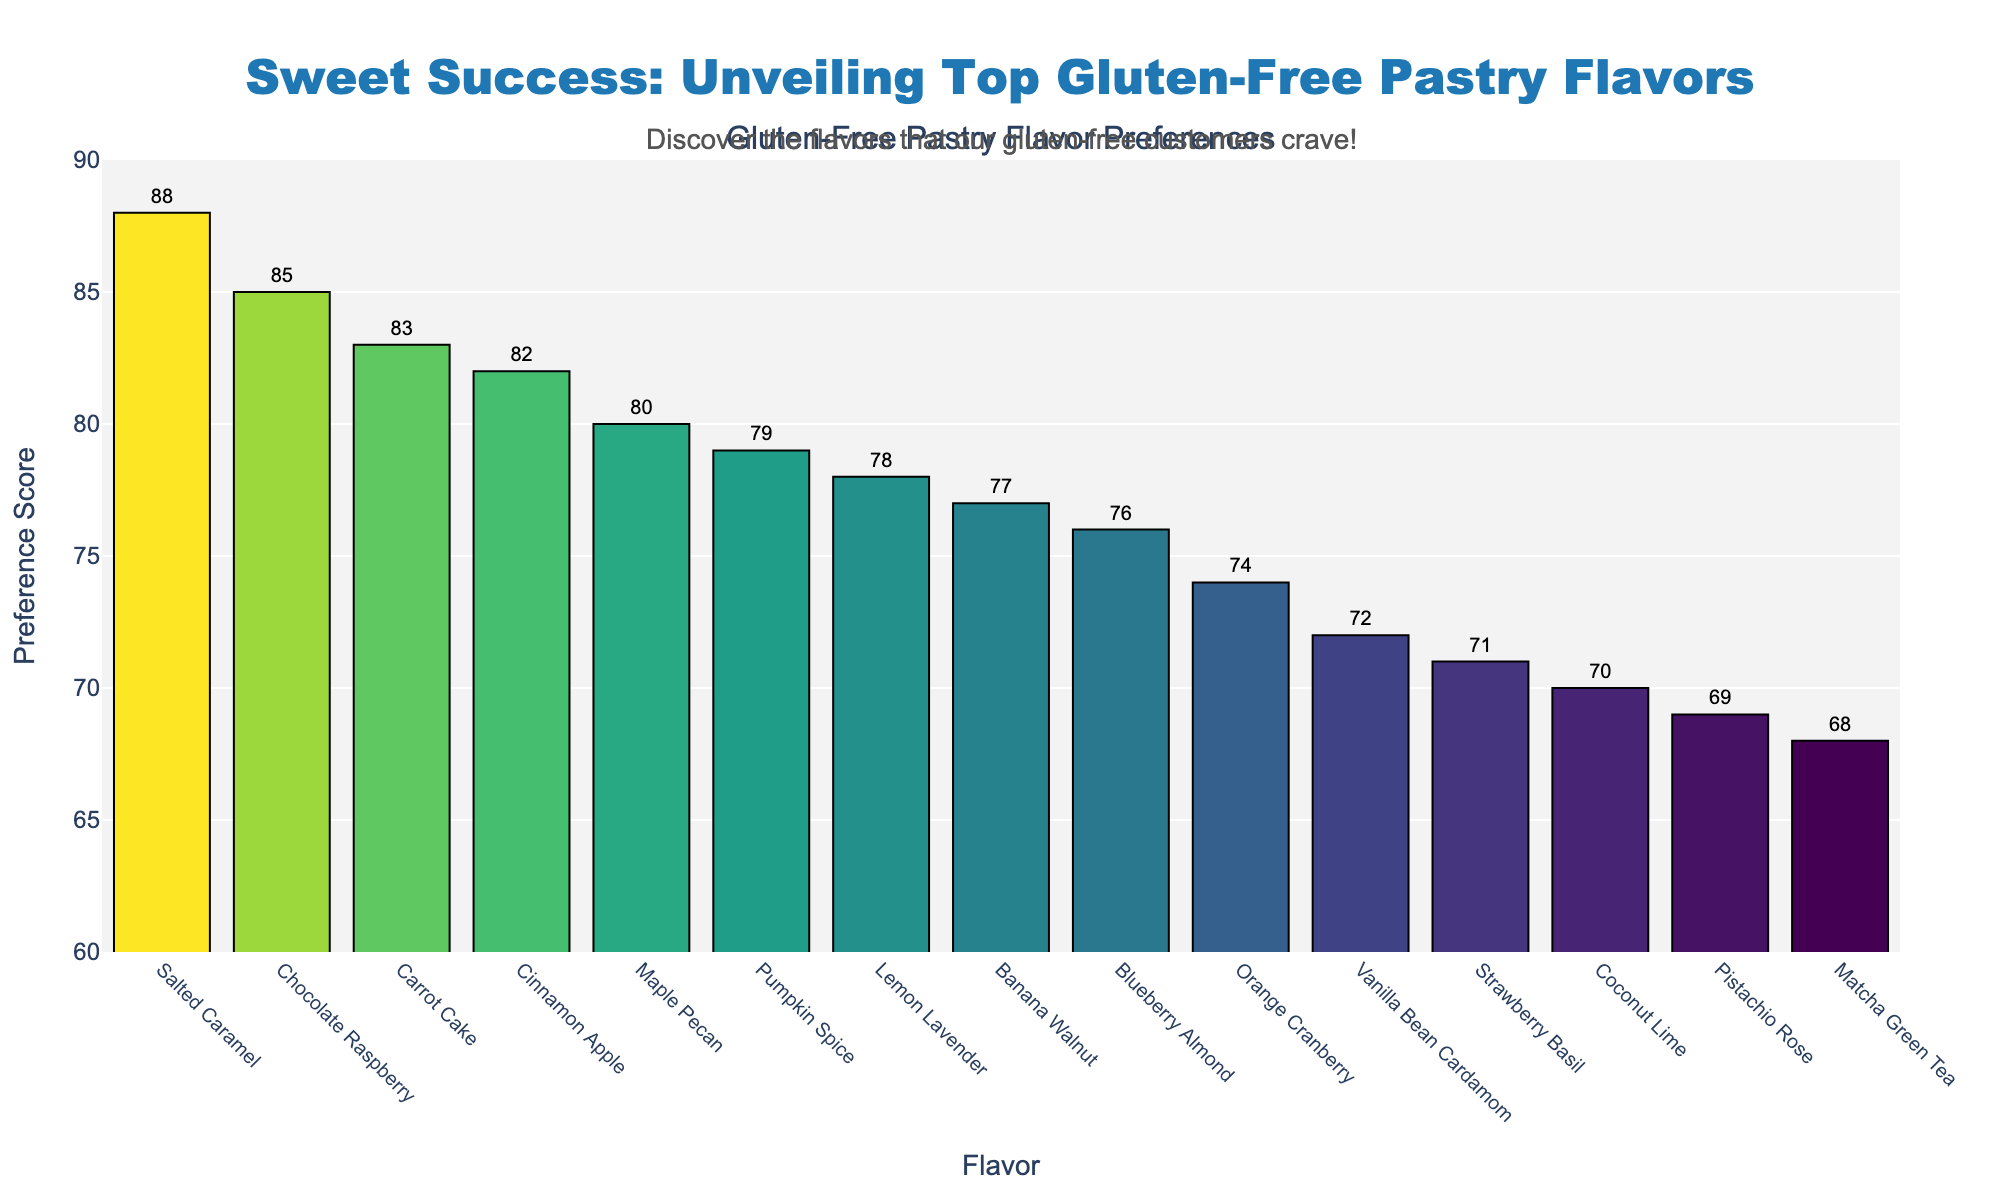Which gluten-free pastry flavor has the highest preference score? To find the highest preference score, look for the tallest bar in the chart. The top flavor is Salted Caramel.
Answer: Salted Caramel What's the sum of the preference scores for Chocolate Raspberry and Cinnamon Apple? Locate the preference scores for Chocolate Raspberry and Cinnamon Apple (85 and 82, respectively). Add these together: 85 + 82 = 167.
Answer: 167 Which flavors have a preference score greater than 80? Identify bars above the 80 mark on the y-axis. These flavors are Salted Caramel, Chocolate Raspberry, Carrot Cake, and Cinnamon Apple.
Answer: Salted Caramel, Chocolate Raspberry, Carrot Cake, Cinnamon Apple What is the average preference score of Vanilla Bean Cardamom, Orange Cranberry, and Pistachio Rose? Find the scores for Vanilla Bean Cardamom (72), Orange Cranberry (74), and Pistachio Rose (69). Add and divide by 3: (72 + 74 + 69) / 3 = 71.67.
Answer: 71.67 Which flavor has a lower preference score, Blueberry Almond or Coconut Lime? Compare the heights of Blueberry Almond and Coconut Lime bars. Blueberry Almond is 76, Coconut Lime is 70, so Coconut Lime is lower.
Answer: Coconut Lime What's the difference in preference score between the highest and the lowest rated flavors? Identify the highest (Salted Caramel, 88) and lowest (Matcha Green Tea, 68) scores. Subtract to find the difference: 88 - 68 = 20.
Answer: 20 What are the three least popular flavors based on preference score? Look at the shortest bars for the lowest scores, which are Coconut Lime (70), Matcha Green Tea (68), and Pistachio Rose (69).
Answer: Matcha Green Tea, Pistachio Rose, Coconut Lime Which has a higher preference score, Lemon Lavender or Pumpkin Spice? Compare the heights of Lemon Lavender and Pumpkin Spice bars. Lemon Lavender is 78, Pumpkin Spice is 79, so Pumpkin Spice is higher.
Answer: Pumpkin Spice What is the median preference score of all flavors? Sort all preference scores and find the middle value. Sorted scores: 68, 69, 70, 71, 72, 74, 76, 77, 78, 79, 80, 82, 83, 85, 88. The median, or the middle value, is 76.
Answer: 76 